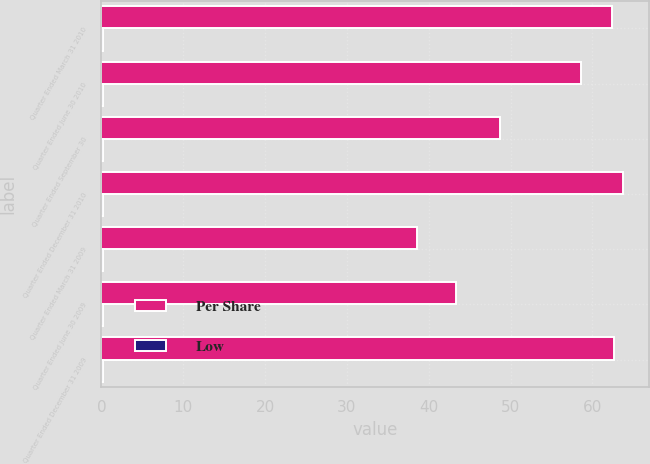Convert chart. <chart><loc_0><loc_0><loc_500><loc_500><stacked_bar_chart><ecel><fcel>Quarter Ended March 31 2010<fcel>Quarter Ended June 30 2010<fcel>Quarter Ended September 30<fcel>Quarter Ended December 31 2010<fcel>Quarter Ended March 31 2009<fcel>Quarter Ended June 30 2009<fcel>Quarter Ended December 31 2009<nl><fcel>Per Share<fcel>62.38<fcel>58.58<fcel>48.74<fcel>63.76<fcel>38.55<fcel>43.35<fcel>62.6<nl><fcel>Low<fcel>0.16<fcel>0.16<fcel>0.16<fcel>0.16<fcel>0.16<fcel>0.16<fcel>0.16<nl></chart> 